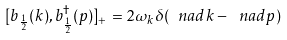Convert formula to latex. <formula><loc_0><loc_0><loc_500><loc_500>[ b _ { \frac { 1 } { 2 } } ( k ) , b ^ { \dagger } _ { \frac { 1 } { 2 } } ( p ) ] _ { + } = 2 \omega _ { k } \delta ( \ n a d { k } - \ n a d { p } )</formula> 